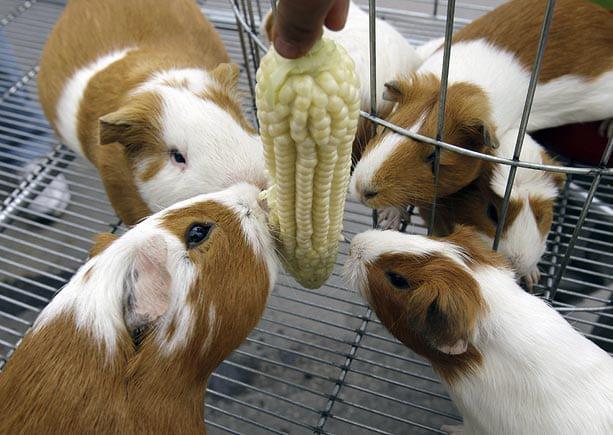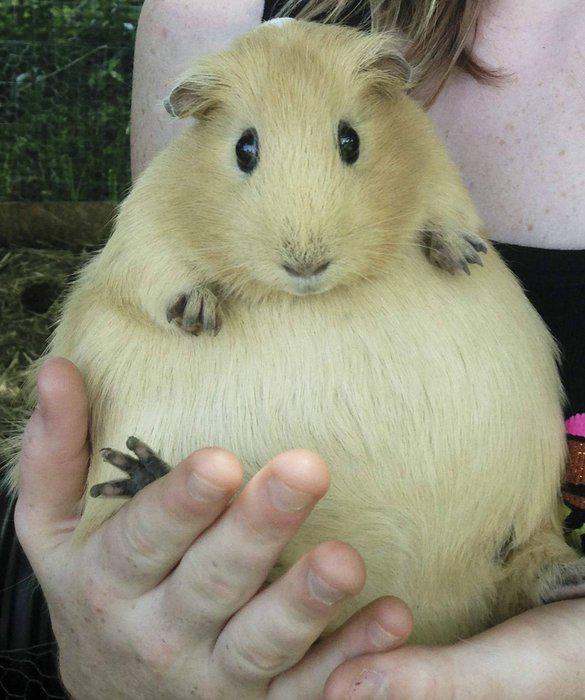The first image is the image on the left, the second image is the image on the right. Evaluate the accuracy of this statement regarding the images: "There are three guinea pigs huddled up closely together in one picture of both pairs.". Is it true? Answer yes or no. No. The first image is the image on the left, the second image is the image on the right. Analyze the images presented: Is the assertion "All of the four hamsters have different color patterns and none of them are eating." valid? Answer yes or no. No. 